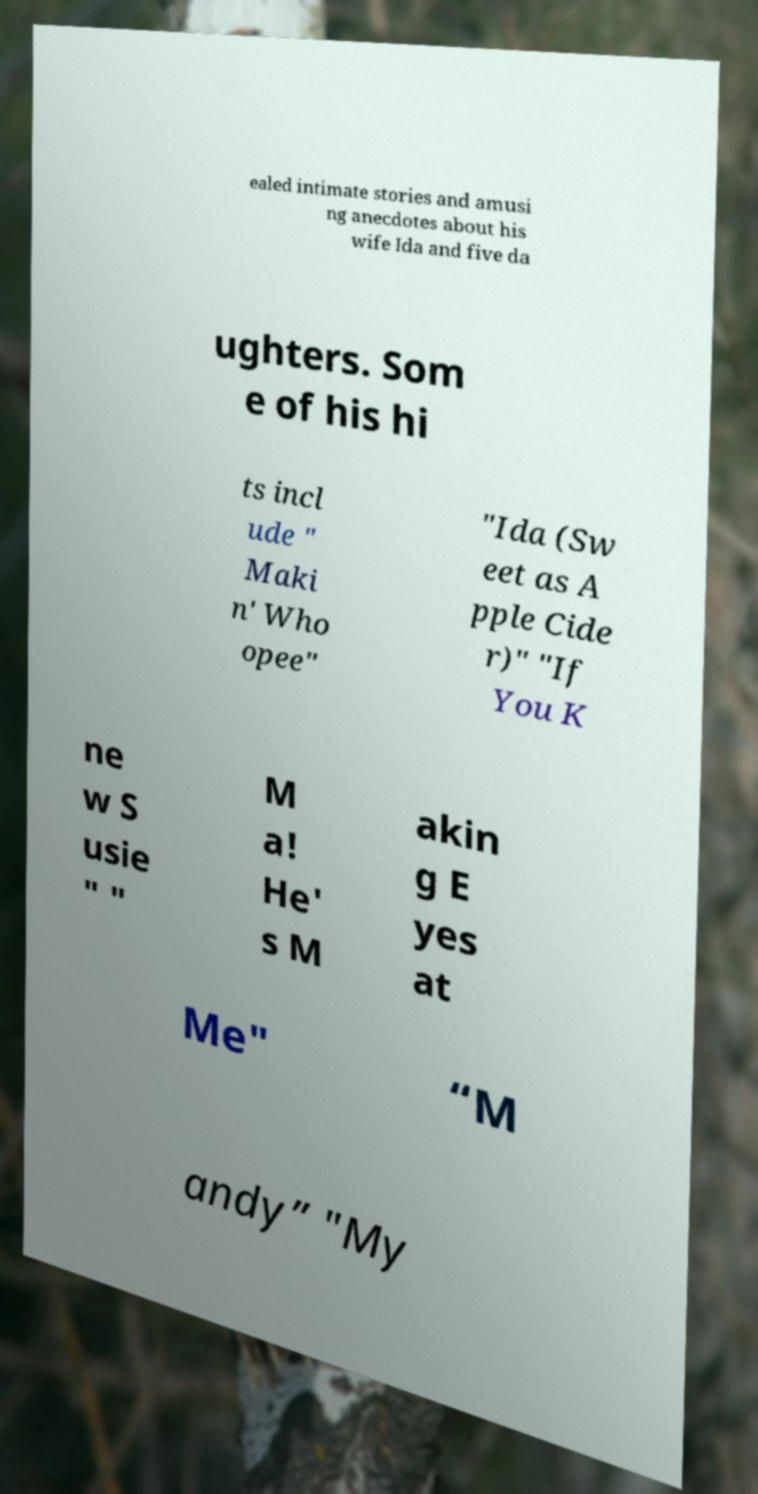What messages or text are displayed in this image? I need them in a readable, typed format. ealed intimate stories and amusi ng anecdotes about his wife Ida and five da ughters. Som e of his hi ts incl ude " Maki n' Who opee" "Ida (Sw eet as A pple Cide r)" "If You K ne w S usie " " M a! He' s M akin g E yes at Me" “M andy” "My 